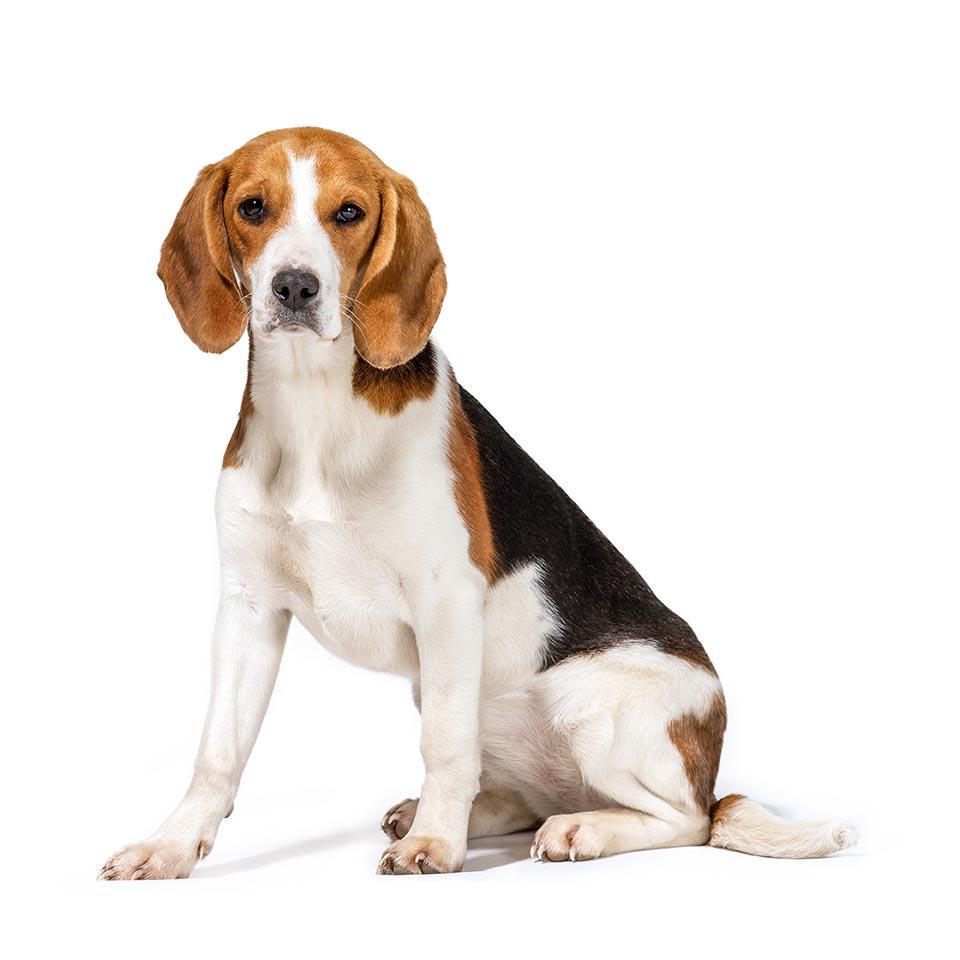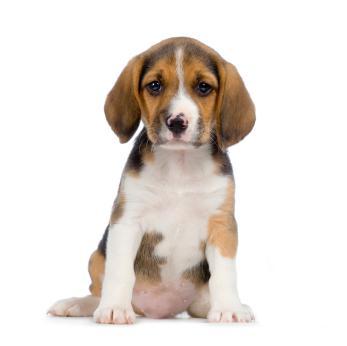The first image is the image on the left, the second image is the image on the right. For the images displayed, is the sentence "both dogs are sitting with its front legs up." factually correct? Answer yes or no. Yes. 